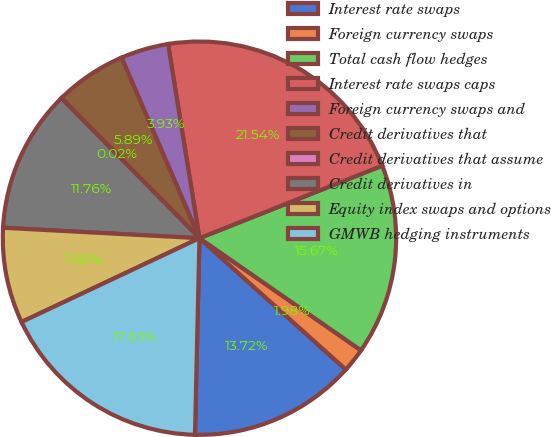Convert chart. <chart><loc_0><loc_0><loc_500><loc_500><pie_chart><fcel>Interest rate swaps<fcel>Foreign currency swaps<fcel>Total cash flow hedges<fcel>Interest rate swaps caps<fcel>Foreign currency swaps and<fcel>Credit derivatives that<fcel>Credit derivatives that assume<fcel>Credit derivatives in<fcel>Equity index swaps and options<fcel>GMWB hedging instruments<nl><fcel>13.72%<fcel>1.98%<fcel>15.67%<fcel>21.54%<fcel>3.93%<fcel>5.89%<fcel>0.02%<fcel>11.76%<fcel>7.85%<fcel>17.63%<nl></chart> 